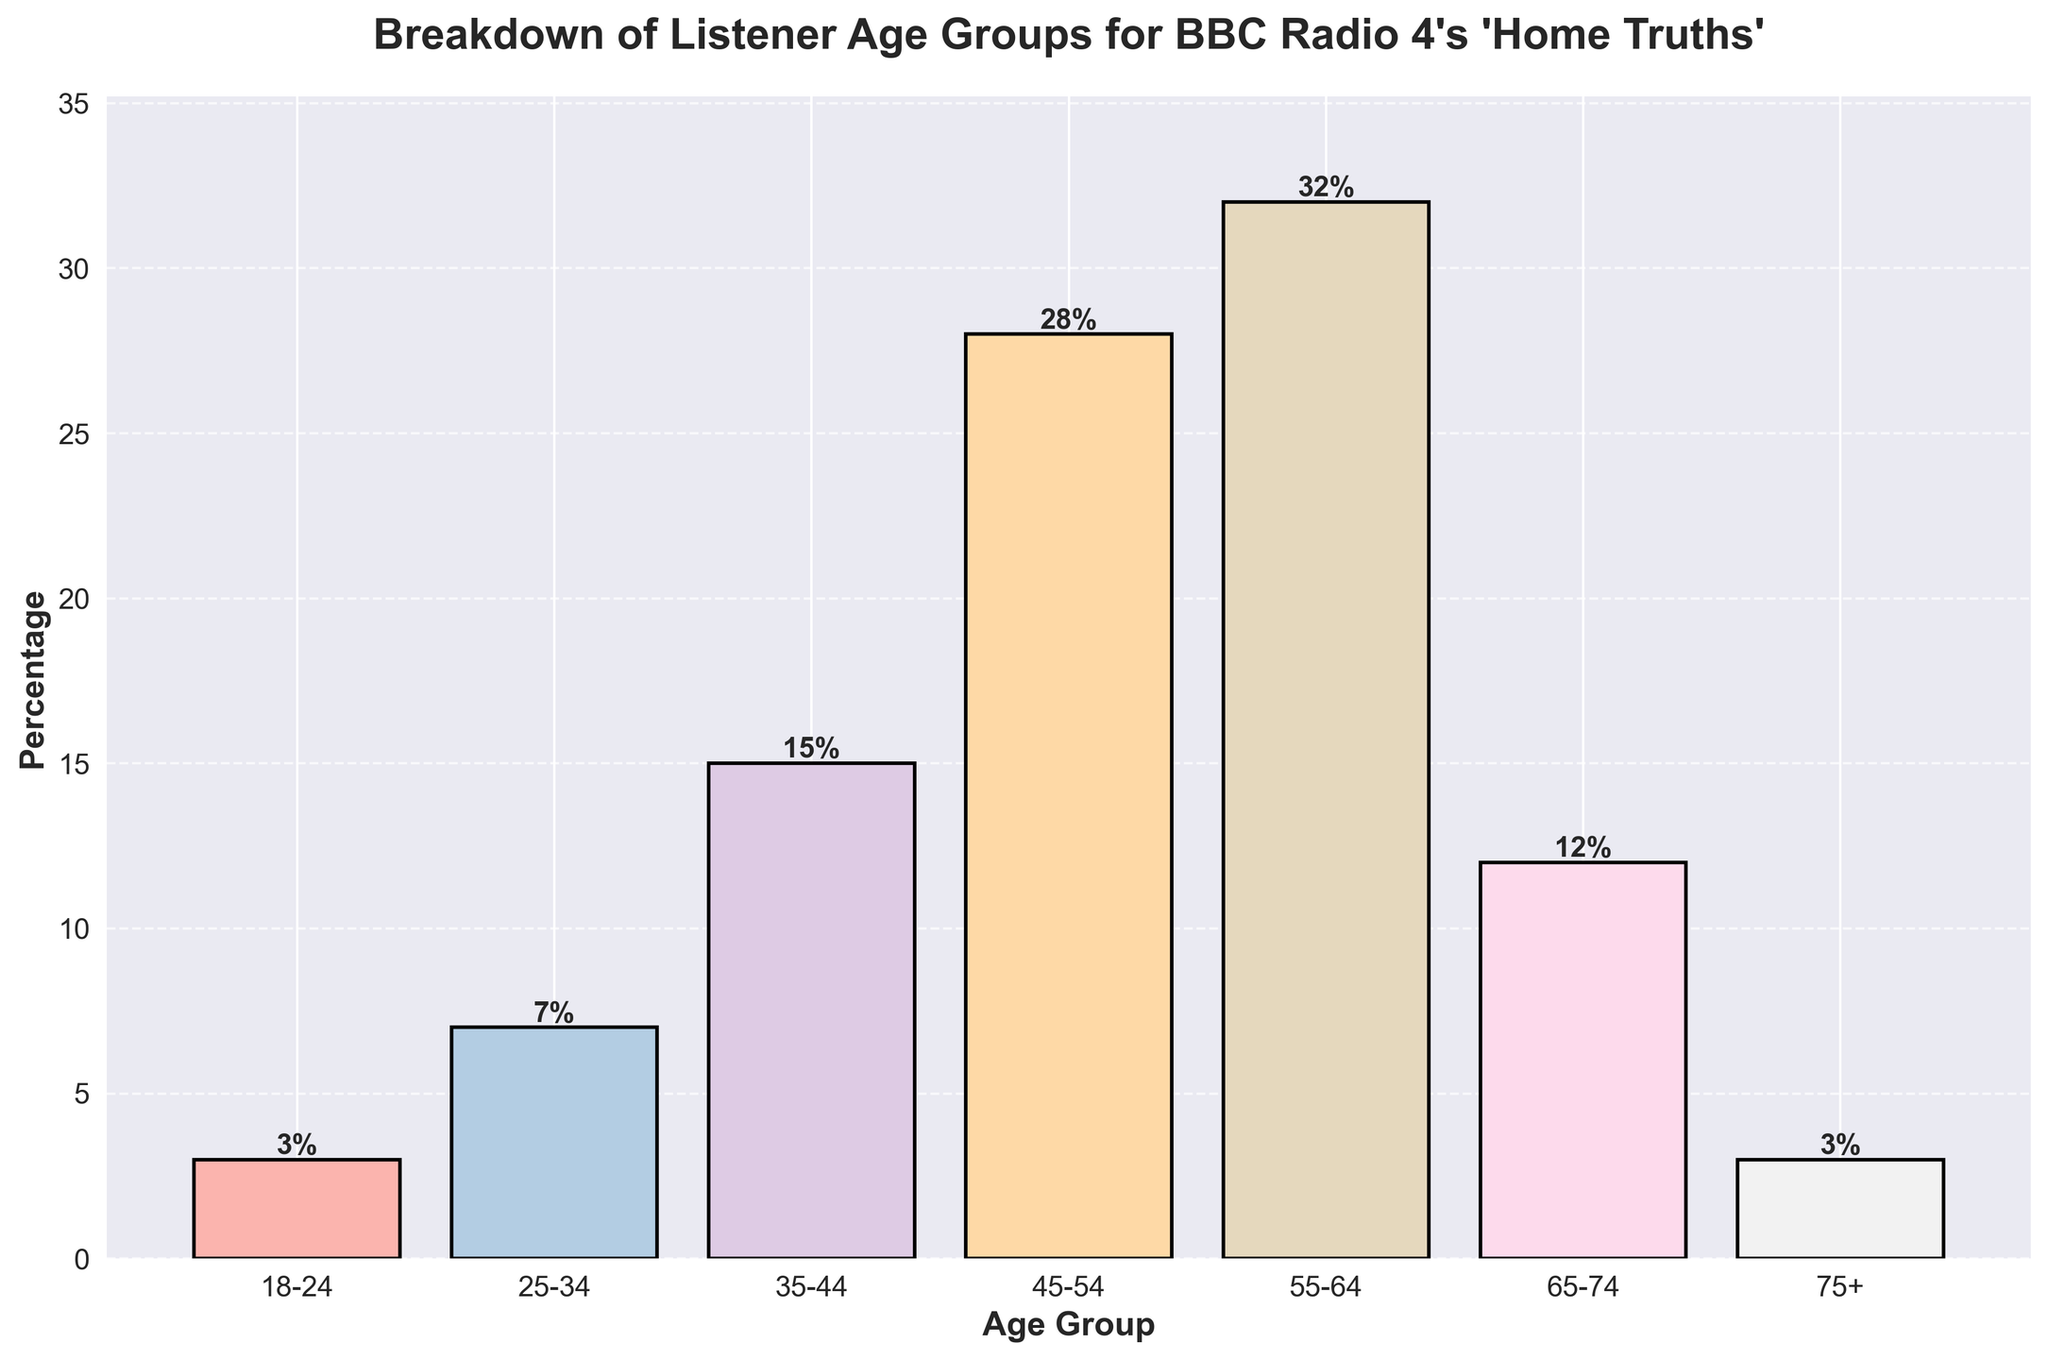What age group has the highest percentage of listeners for BBC Radio 4's 'Home Truths'? To answer this, we need to look at the heights of the bars on the chart. The tallest bar corresponds to the age group 55-64. Thus, this group has the highest percentage of listeners.
Answer: 55-64 Which two age groups have an equal percentage of listeners? Look at the bars with the same height. The bars for age groups 18-24 and 75+ are of equal height, both representing a percentage of 3.
Answer: 18-24 and 75+ What is the combined percentage of listeners aged 25-34 and 35-44? Add the percentages for the two age groups: 7 (25-34) + 15 (35-44) = 22.
Answer: 22 Which age group has a higher percentage of listeners, 45-54 or 65-74? Compare the heights of the bars. The bar for age group 45-54 is higher than the bar for age group 65-74, meaning 45-54 has a higher percentage of listeners.
Answer: 45-54 What is the total percentage of listeners in the 18-24, 25-34, and 75+ age groups together? Add the percentages for these groups: 3 (18-24) + 7 (25-34) + 3 (75+) = 13.
Answer: 13 Which age group has the lowest percentage of listeners? Locate the shortest bar on the chart. The bars for age groups 18-24 and 75+ are the shortest, each at 3%. However, since these share the same percentage, either can be an acceptable answer.
Answer: 18-24 or 75+ What is the difference in the percentage of listeners between age groups 55-64 and 65-74? Subtract the percentage of 65-74 from that of 55-64: 32 (55-64) - 12 (65-74) = 20.
Answer: 20 How many age groups have a percentage of listeners greater than 20%? Determine the height of each bar and count those above 20%. The 45-54 (28%) and 55-64 (32%) groups are the only ones exceeding 20%.
Answer: 2 Estimate the median percentage of listeners across all age groups. Order the percentages: 3, 3, 7, 12, 15, 28, 32. The median is the middle value of this ordered list, which is 12.
Answer: 12 